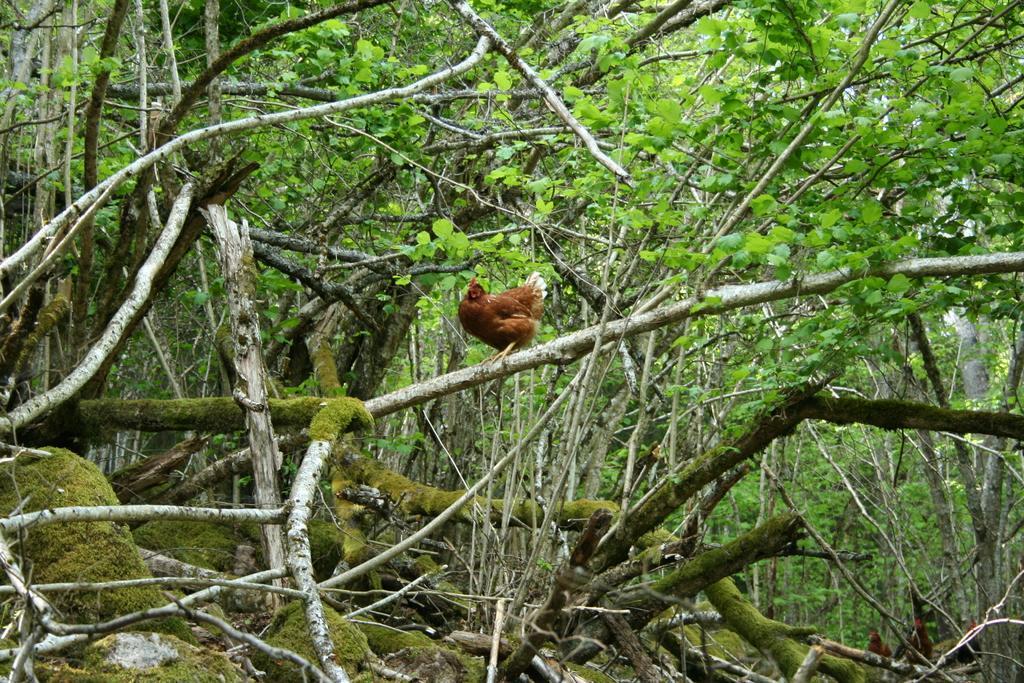Describe this image in one or two sentences. In this image there is a hen standing on the branch of a tree. Around the hen there are trees. 